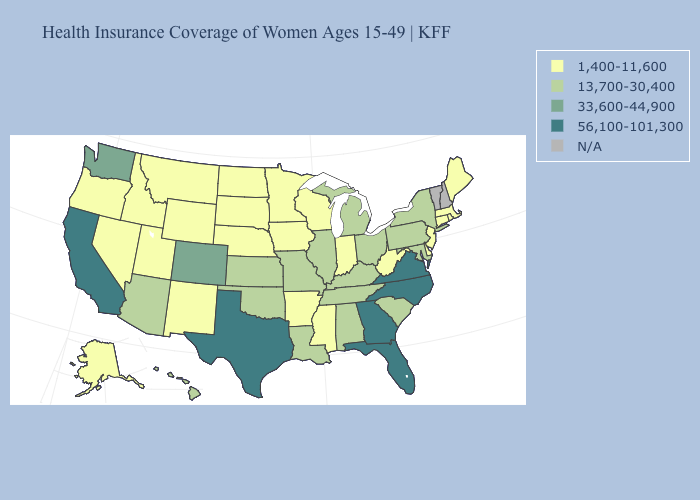What is the value of Massachusetts?
Keep it brief. 1,400-11,600. Among the states that border Delaware , which have the highest value?
Write a very short answer. Maryland, Pennsylvania. What is the highest value in the Northeast ?
Be succinct. 13,700-30,400. What is the value of Kansas?
Be succinct. 13,700-30,400. What is the value of South Dakota?
Be succinct. 1,400-11,600. What is the value of Arizona?
Be succinct. 13,700-30,400. Among the states that border Arizona , which have the lowest value?
Give a very brief answer. Nevada, New Mexico, Utah. Does the first symbol in the legend represent the smallest category?
Quick response, please. Yes. What is the value of Delaware?
Keep it brief. 1,400-11,600. Among the states that border Illinois , which have the lowest value?
Give a very brief answer. Indiana, Iowa, Wisconsin. What is the lowest value in states that border Virginia?
Answer briefly. 1,400-11,600. Does Virginia have the highest value in the USA?
Answer briefly. Yes. Name the states that have a value in the range 33,600-44,900?
Give a very brief answer. Colorado, Washington. 